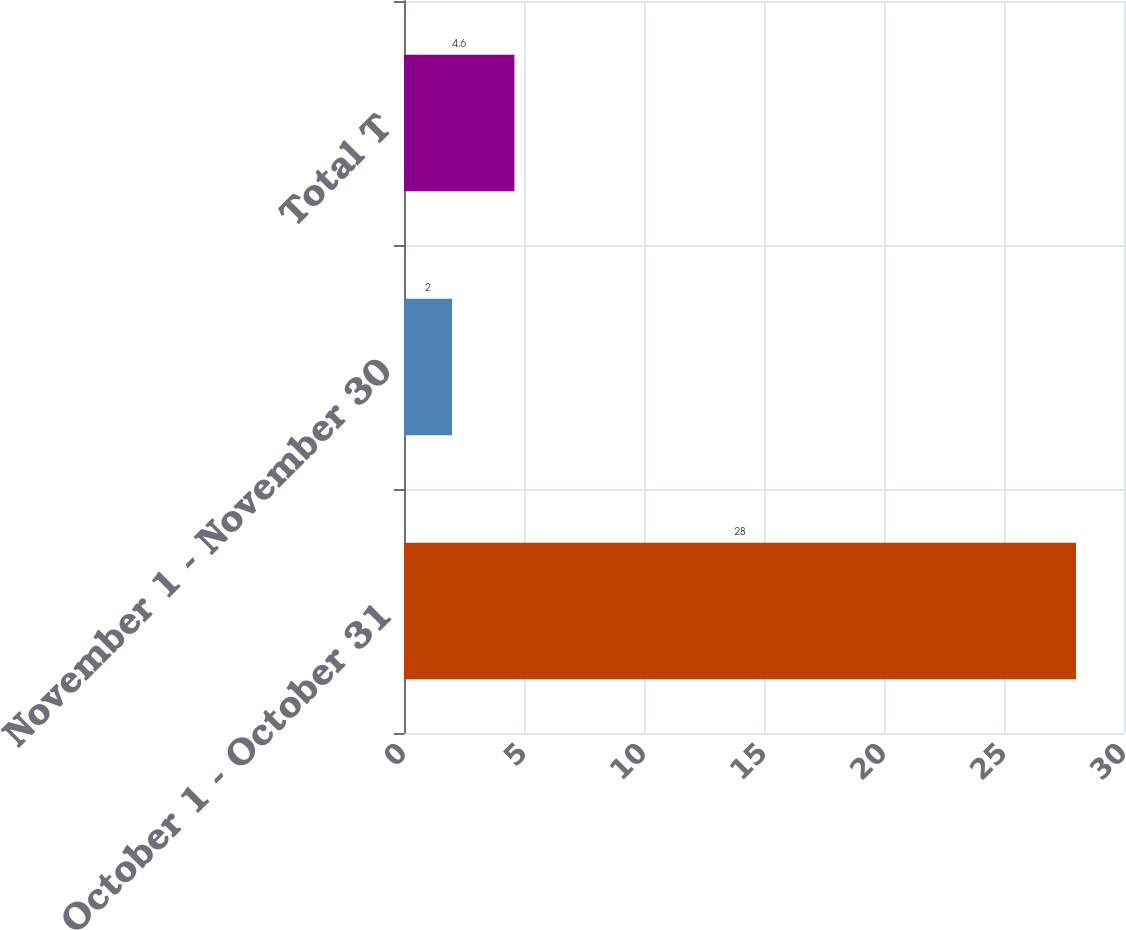<chart> <loc_0><loc_0><loc_500><loc_500><bar_chart><fcel>October 1 - October 31<fcel>November 1 - November 30<fcel>Total T<nl><fcel>28<fcel>2<fcel>4.6<nl></chart> 